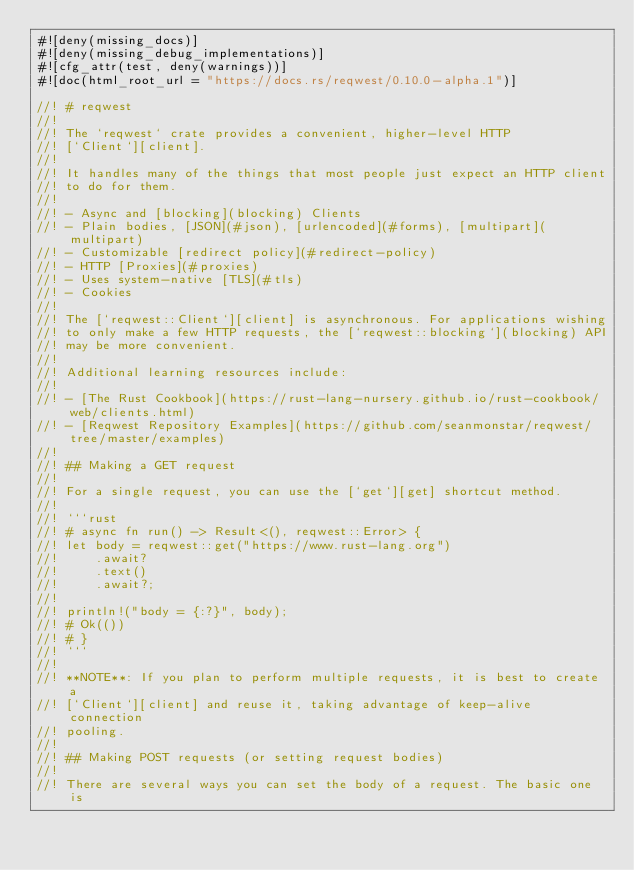<code> <loc_0><loc_0><loc_500><loc_500><_Rust_>#![deny(missing_docs)]
#![deny(missing_debug_implementations)]
#![cfg_attr(test, deny(warnings))]
#![doc(html_root_url = "https://docs.rs/reqwest/0.10.0-alpha.1")]

//! # reqwest
//!
//! The `reqwest` crate provides a convenient, higher-level HTTP
//! [`Client`][client].
//!
//! It handles many of the things that most people just expect an HTTP client
//! to do for them.
//!
//! - Async and [blocking](blocking) Clients
//! - Plain bodies, [JSON](#json), [urlencoded](#forms), [multipart](multipart)
//! - Customizable [redirect policy](#redirect-policy)
//! - HTTP [Proxies](#proxies)
//! - Uses system-native [TLS](#tls)
//! - Cookies
//!
//! The [`reqwest::Client`][client] is asynchronous. For applications wishing
//! to only make a few HTTP requests, the [`reqwest::blocking`](blocking) API
//! may be more convenient.
//!
//! Additional learning resources include:
//!
//! - [The Rust Cookbook](https://rust-lang-nursery.github.io/rust-cookbook/web/clients.html)
//! - [Reqwest Repository Examples](https://github.com/seanmonstar/reqwest/tree/master/examples)
//!
//! ## Making a GET request
//!
//! For a single request, you can use the [`get`][get] shortcut method.
//!
//! ```rust
//! # async fn run() -> Result<(), reqwest::Error> {
//! let body = reqwest::get("https://www.rust-lang.org")
//!     .await?
//!     .text()
//!     .await?;
//!
//! println!("body = {:?}", body);
//! # Ok(())
//! # }
//! ```
//!
//! **NOTE**: If you plan to perform multiple requests, it is best to create a
//! [`Client`][client] and reuse it, taking advantage of keep-alive connection
//! pooling.
//!
//! ## Making POST requests (or setting request bodies)
//!
//! There are several ways you can set the body of a request. The basic one is</code> 